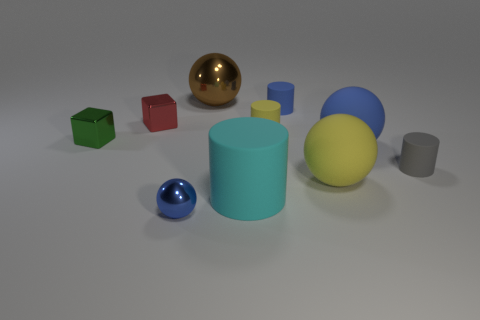Subtract all red blocks. Subtract all green cylinders. How many blocks are left? 1 Subtract all cylinders. How many objects are left? 6 Add 2 large gray matte cylinders. How many large gray matte cylinders exist? 2 Subtract 0 brown cylinders. How many objects are left? 10 Subtract all brown objects. Subtract all tiny blue shiny balls. How many objects are left? 8 Add 4 large spheres. How many large spheres are left? 7 